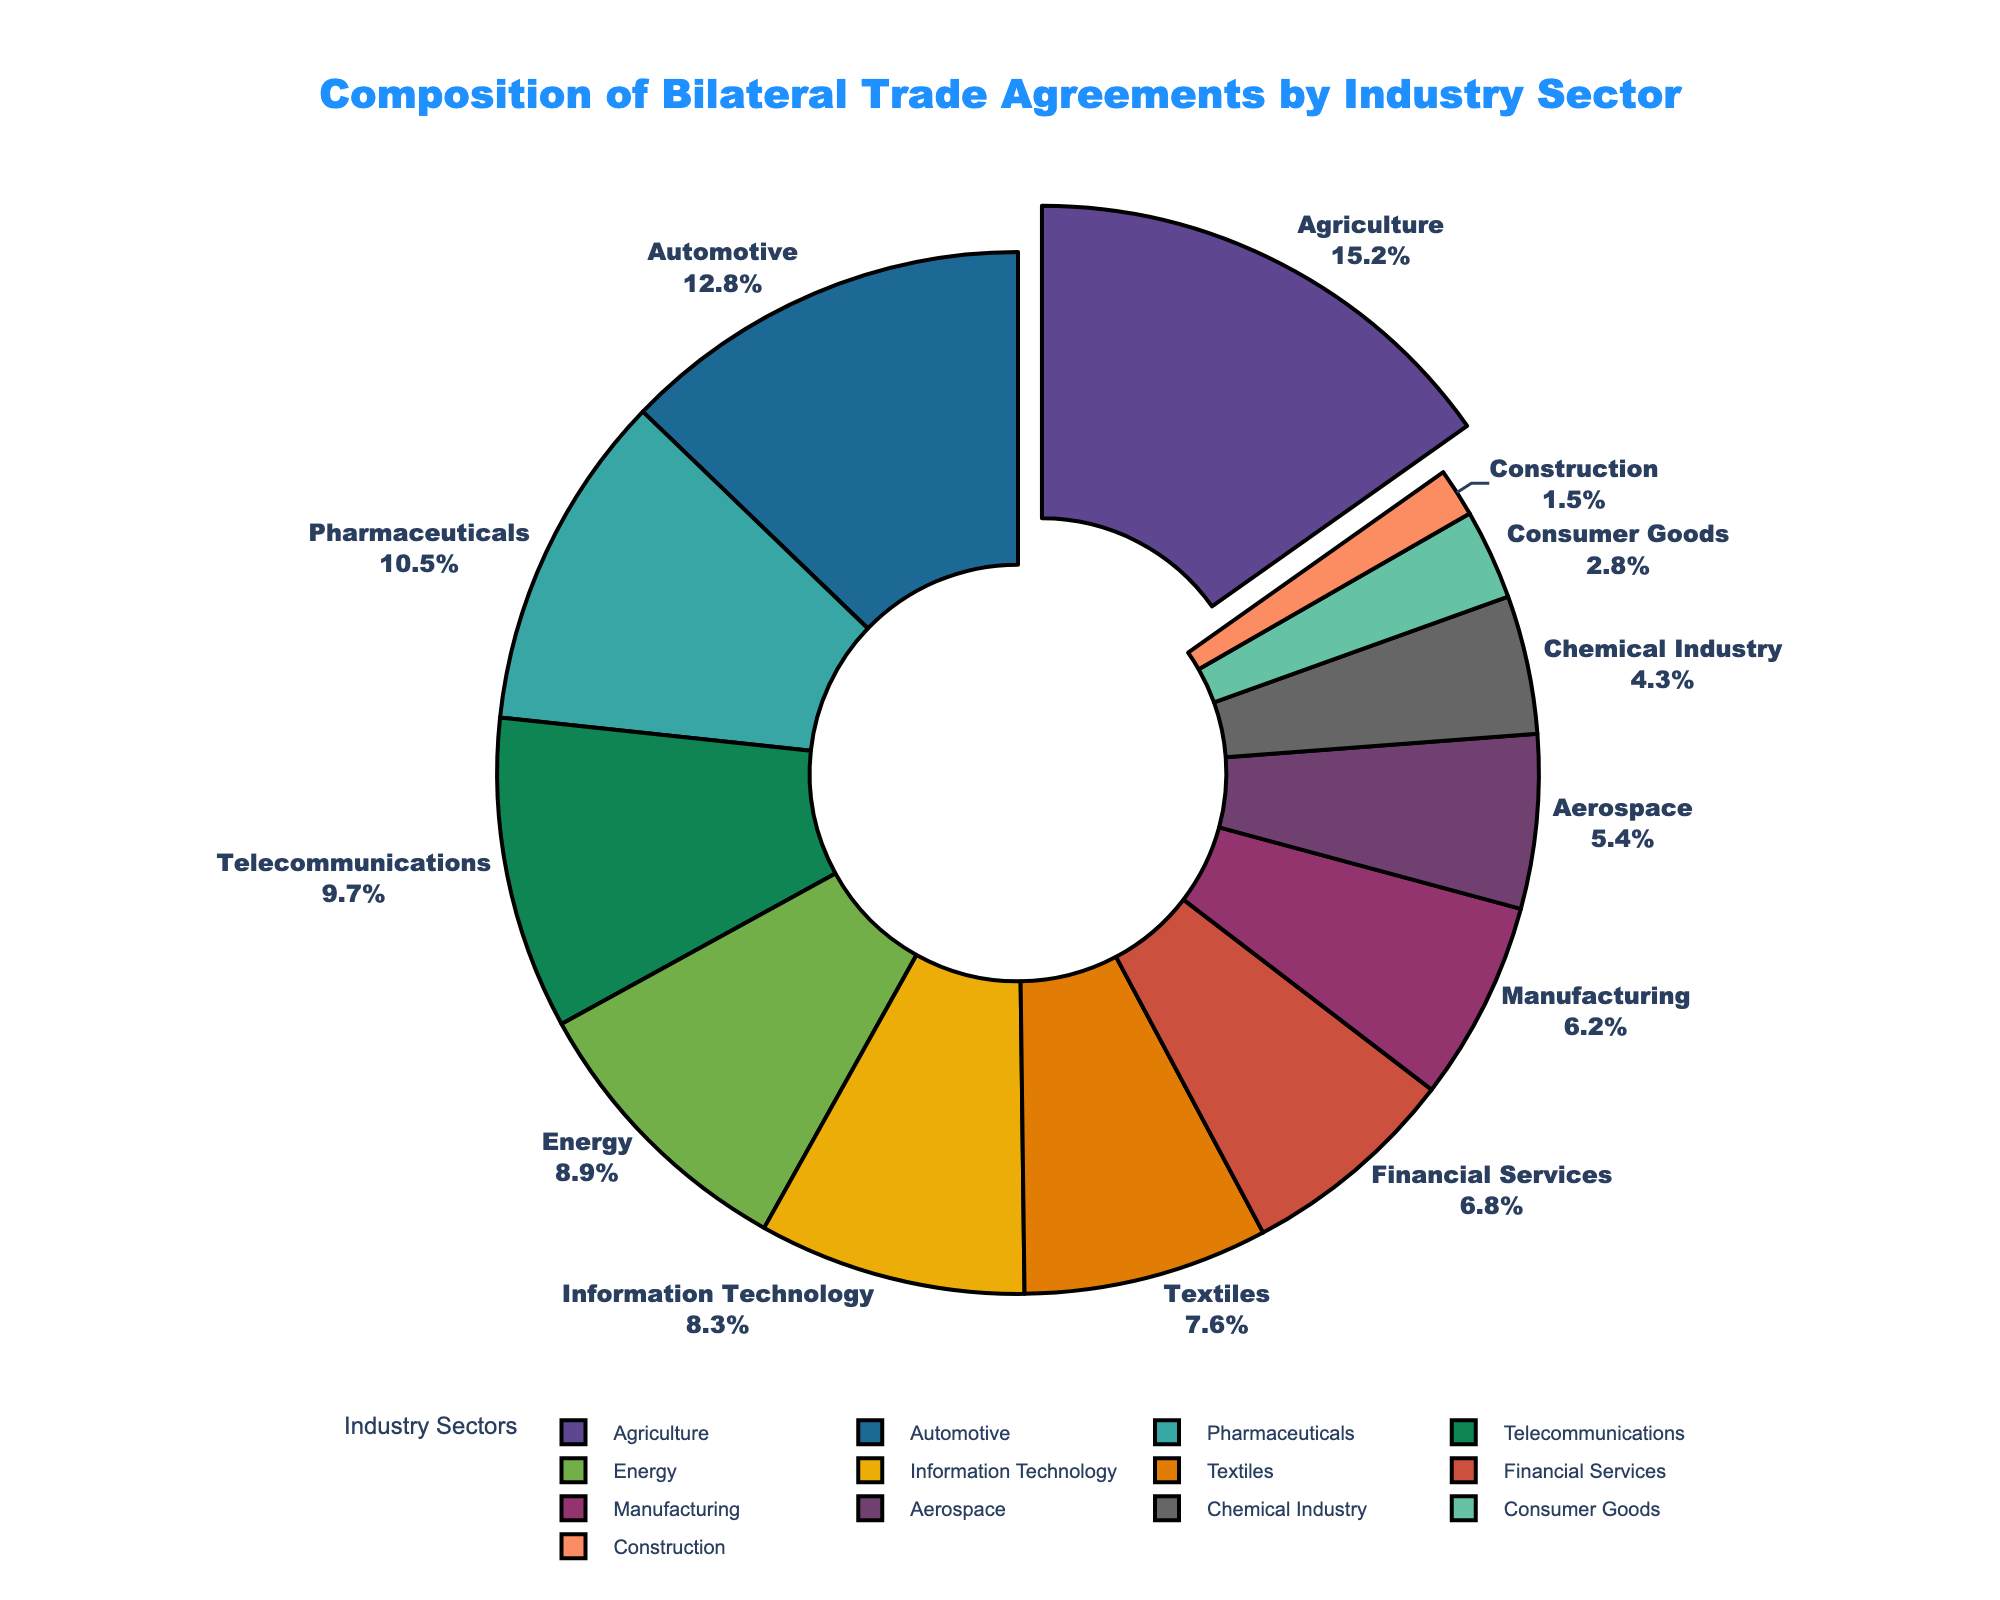Which industry sector has the highest percentage in bilateral trade agreements? By looking at the pie chart, the pulled-out (highlighted) segment represents the industry sector with the highest percentage. The label on this segment indicates "Agriculture" with 15.2%.
Answer: Agriculture What is the combined percentage of the Automotive and Pharmaceuticals sectors? From the pie chart, the percentages for the Automotive and Pharmaceuticals sectors are 12.8% and 10.5%, respectively. Adding them gives us 12.8 + 10.5 = 23.3%.
Answer: 23.3% Which industry sector has a larger percentage, Energy or Telecommunications? From the pie chart, Energy has 8.9%, while Telecommunications has 9.7%. Comparing these values, Telecommunications has a larger percentage.
Answer: Telecommunications What is the total percentage of the top three industry sectors in the bilateral trade agreements? From the pie chart, the top three industry sectors are Agriculture (15.2%), Automotive (12.8%), and Pharmaceuticals (10.5%). Summing these values gives 15.2 + 12.8 + 10.5 = 38.5%.
Answer: 38.5% Which industry sector occupies the smallest segment in bilateral trade agreements? By looking at the pie chart, the smallest segment is labeled "Construction" with 1.5%.
Answer: Construction Compare the combined percentage of Information Technology and Financial Services to Aerospace. Which is larger? From the pie chart, Information Technology and Financial Services are 8.3% and 6.8%, respectively. Their combined percentage is 8.3 + 6.8 = 15.1%. Aerospace is 5.4%. Comparing 15.1% to 5.4%, the combined percentage of Information Technology and Financial Services is larger.
Answer: Information Technology and Financial Services How much larger is the percentage of Agriculture compared to Textiles? From the pie chart, Agriculture has 15.2%, and Textiles have 7.6%. The difference is 15.2 - 7.6 = 7.6%.
Answer: 7.6% What is the average percentage of the sectors that have between 8% and 10%? From the pie chart, the sectors in this range are Telecommunications (9.7%), Energy (8.9%), and Information Technology (8.3%). Summing these values gives 9.7 + 8.9 + 8.3 = 26.9%. The average is 26.9 / 3 = 8.97%.
Answer: 8.97% Which sector is visually represented with a green color in the pie chart? To determine the sector represented by the green color in the pie chart, refer to the visual attribute of the segment colored green. Based on this, the Telecommunications sector is colored green.
Answer: Telecommunications 